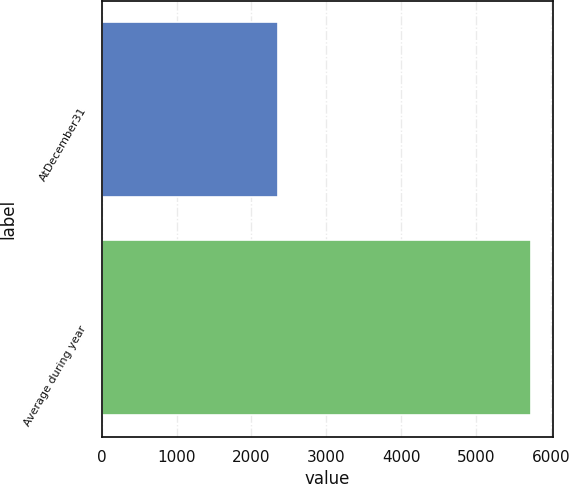Convert chart to OTSL. <chart><loc_0><loc_0><loc_500><loc_500><bar_chart><fcel>AtDecember31<fcel>Average during year<nl><fcel>2356<fcel>5736<nl></chart> 